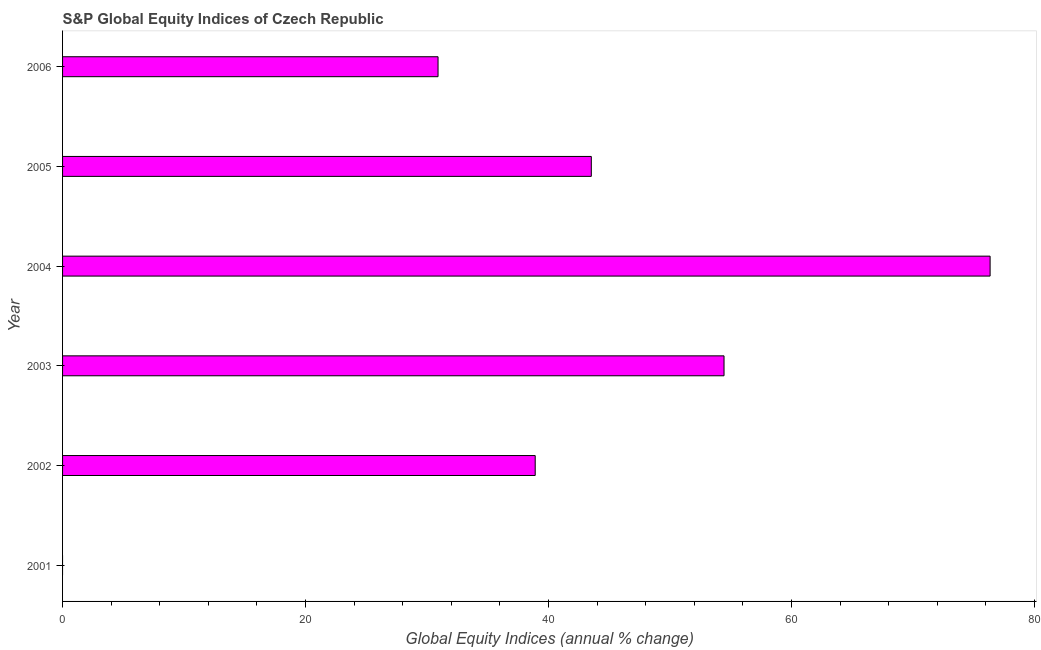Does the graph contain any zero values?
Make the answer very short. Yes. Does the graph contain grids?
Offer a terse response. No. What is the title of the graph?
Offer a terse response. S&P Global Equity Indices of Czech Republic. What is the label or title of the X-axis?
Provide a succinct answer. Global Equity Indices (annual % change). What is the label or title of the Y-axis?
Offer a terse response. Year. What is the s&p global equity indices in 2005?
Provide a succinct answer. 43.52. Across all years, what is the maximum s&p global equity indices?
Offer a very short reply. 76.34. In which year was the s&p global equity indices maximum?
Make the answer very short. 2004. What is the sum of the s&p global equity indices?
Your answer should be compact. 244.1. What is the difference between the s&p global equity indices in 2002 and 2004?
Keep it short and to the point. -37.44. What is the average s&p global equity indices per year?
Provide a short and direct response. 40.68. What is the median s&p global equity indices?
Offer a terse response. 41.21. In how many years, is the s&p global equity indices greater than 28 %?
Give a very brief answer. 5. What is the ratio of the s&p global equity indices in 2004 to that in 2005?
Provide a short and direct response. 1.75. Is the s&p global equity indices in 2003 less than that in 2005?
Keep it short and to the point. No. What is the difference between the highest and the second highest s&p global equity indices?
Your response must be concise. 21.9. What is the difference between the highest and the lowest s&p global equity indices?
Your answer should be compact. 76.34. In how many years, is the s&p global equity indices greater than the average s&p global equity indices taken over all years?
Your answer should be compact. 3. How many bars are there?
Give a very brief answer. 5. How many years are there in the graph?
Your answer should be compact. 6. What is the Global Equity Indices (annual % change) of 2002?
Your answer should be compact. 38.9. What is the Global Equity Indices (annual % change) in 2003?
Provide a succinct answer. 54.44. What is the Global Equity Indices (annual % change) in 2004?
Provide a succinct answer. 76.34. What is the Global Equity Indices (annual % change) of 2005?
Your response must be concise. 43.52. What is the Global Equity Indices (annual % change) in 2006?
Keep it short and to the point. 30.9. What is the difference between the Global Equity Indices (annual % change) in 2002 and 2003?
Keep it short and to the point. -15.54. What is the difference between the Global Equity Indices (annual % change) in 2002 and 2004?
Provide a short and direct response. -37.44. What is the difference between the Global Equity Indices (annual % change) in 2002 and 2005?
Offer a very short reply. -4.62. What is the difference between the Global Equity Indices (annual % change) in 2002 and 2006?
Keep it short and to the point. 8. What is the difference between the Global Equity Indices (annual % change) in 2003 and 2004?
Offer a terse response. -21.9. What is the difference between the Global Equity Indices (annual % change) in 2003 and 2005?
Your answer should be compact. 10.92. What is the difference between the Global Equity Indices (annual % change) in 2003 and 2006?
Keep it short and to the point. 23.54. What is the difference between the Global Equity Indices (annual % change) in 2004 and 2005?
Provide a succinct answer. 32.82. What is the difference between the Global Equity Indices (annual % change) in 2004 and 2006?
Ensure brevity in your answer.  45.44. What is the difference between the Global Equity Indices (annual % change) in 2005 and 2006?
Offer a terse response. 12.62. What is the ratio of the Global Equity Indices (annual % change) in 2002 to that in 2003?
Provide a succinct answer. 0.71. What is the ratio of the Global Equity Indices (annual % change) in 2002 to that in 2004?
Make the answer very short. 0.51. What is the ratio of the Global Equity Indices (annual % change) in 2002 to that in 2005?
Ensure brevity in your answer.  0.89. What is the ratio of the Global Equity Indices (annual % change) in 2002 to that in 2006?
Offer a very short reply. 1.26. What is the ratio of the Global Equity Indices (annual % change) in 2003 to that in 2004?
Keep it short and to the point. 0.71. What is the ratio of the Global Equity Indices (annual % change) in 2003 to that in 2005?
Keep it short and to the point. 1.25. What is the ratio of the Global Equity Indices (annual % change) in 2003 to that in 2006?
Make the answer very short. 1.76. What is the ratio of the Global Equity Indices (annual % change) in 2004 to that in 2005?
Keep it short and to the point. 1.75. What is the ratio of the Global Equity Indices (annual % change) in 2004 to that in 2006?
Make the answer very short. 2.47. What is the ratio of the Global Equity Indices (annual % change) in 2005 to that in 2006?
Your answer should be compact. 1.41. 